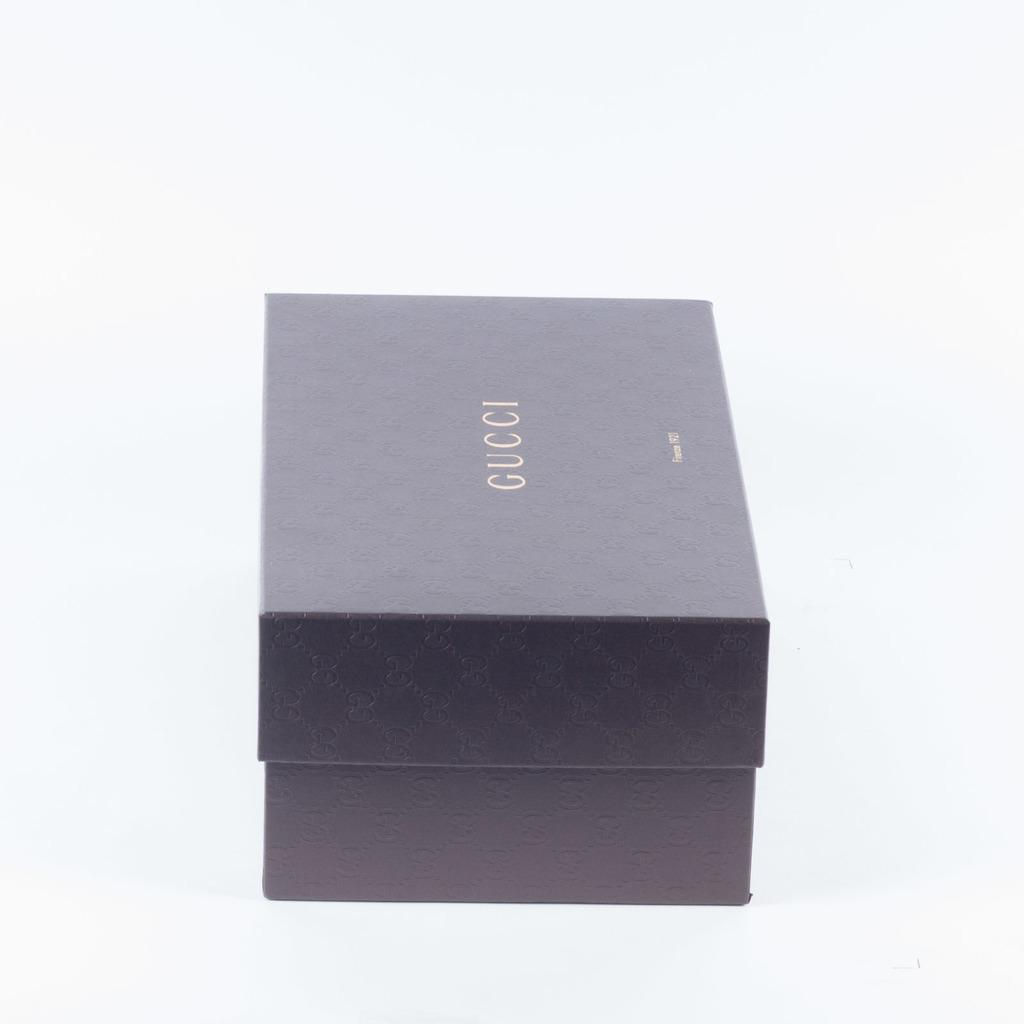Provide a one-sentence caption for the provided image. A small Gucci box sits with the lid on. 